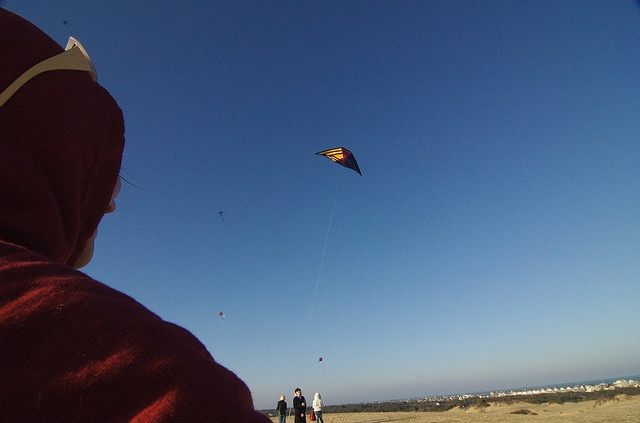Describe the objects in this image and their specific colors. I can see people in navy, black, maroon, and brown tones, kite in navy, black, maroon, and olive tones, people in navy, black, gray, maroon, and brown tones, people in navy, black, gray, and darkgray tones, and people in navy, beige, darkgray, gray, and black tones in this image. 